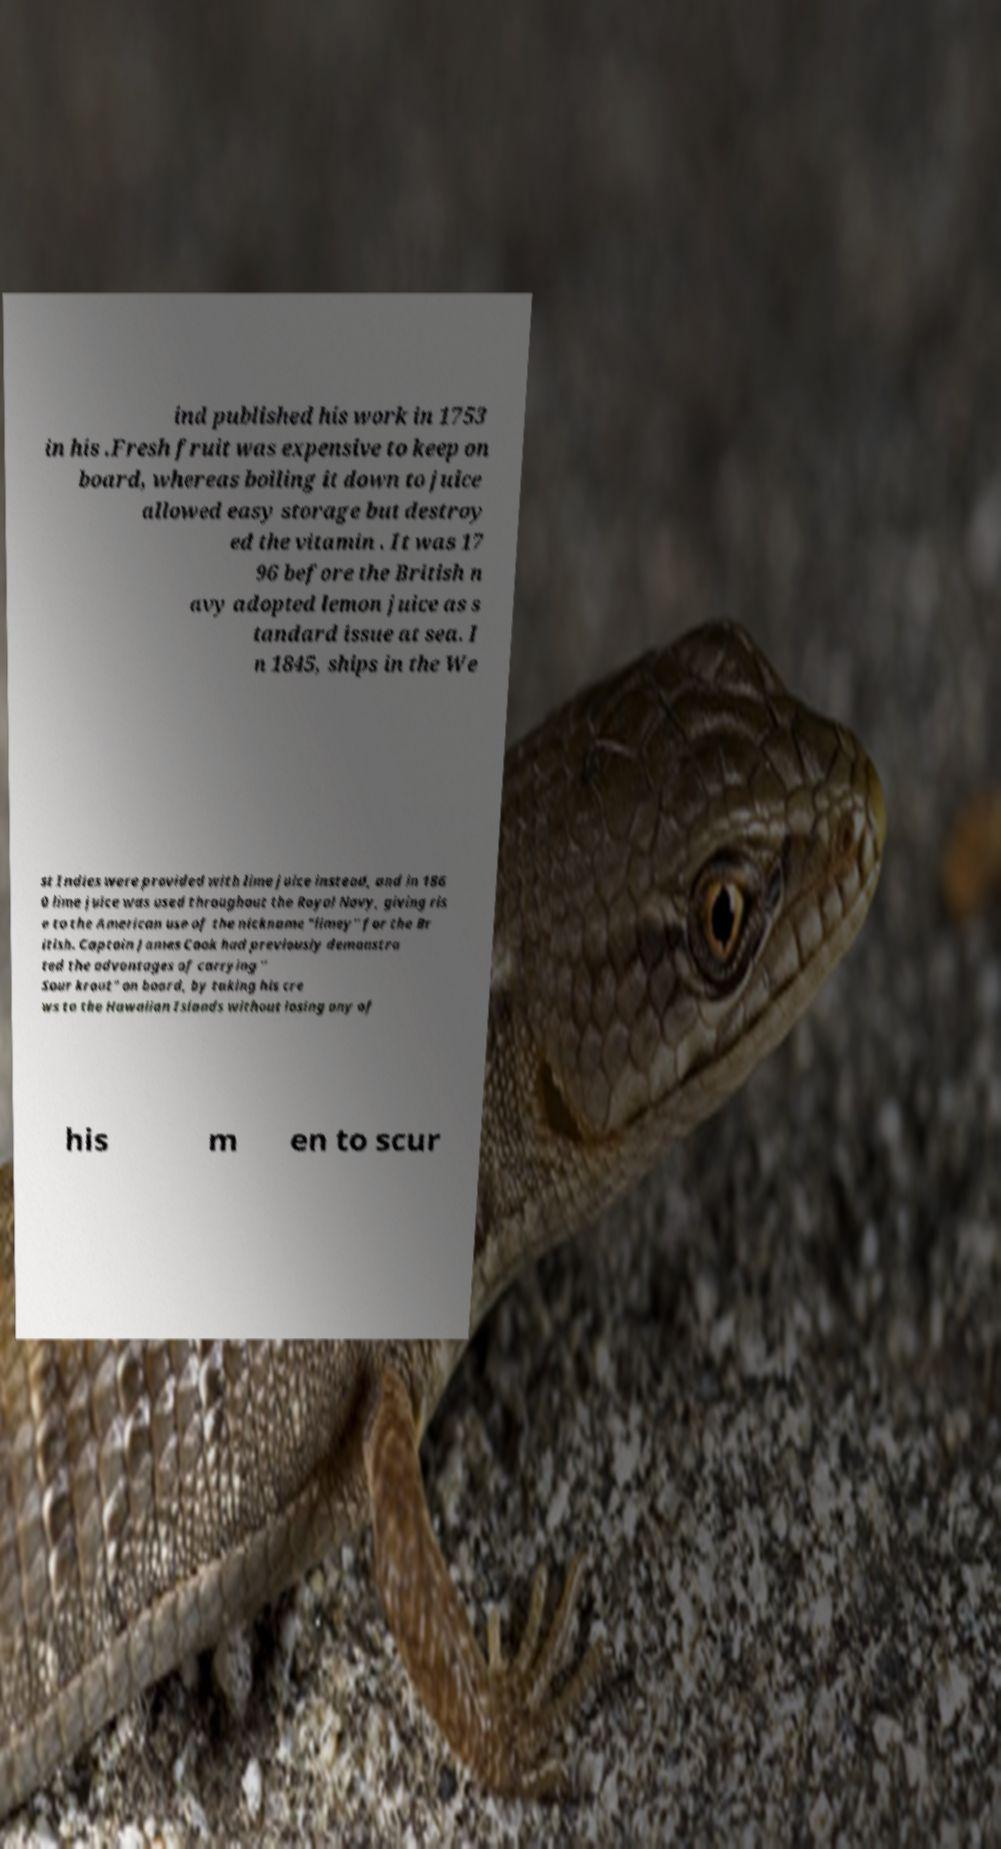Can you read and provide the text displayed in the image?This photo seems to have some interesting text. Can you extract and type it out for me? ind published his work in 1753 in his .Fresh fruit was expensive to keep on board, whereas boiling it down to juice allowed easy storage but destroy ed the vitamin . It was 17 96 before the British n avy adopted lemon juice as s tandard issue at sea. I n 1845, ships in the We st Indies were provided with lime juice instead, and in 186 0 lime juice was used throughout the Royal Navy, giving ris e to the American use of the nickname "limey" for the Br itish. Captain James Cook had previously demonstra ted the advantages of carrying " Sour krout" on board, by taking his cre ws to the Hawaiian Islands without losing any of his m en to scur 